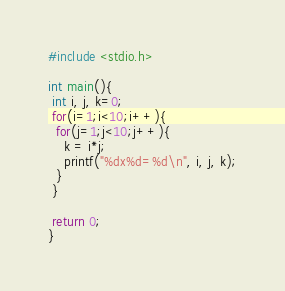Convert code to text. <code><loc_0><loc_0><loc_500><loc_500><_C_>#include <stdio.h>

int main(){
 int i, j, k=0;
 for(i=1;i<10;i++){
  for(j=1;j<10;j++){
    k = i*j;
    printf("%dx%d=%d\n", i, j, k);
  }
 }

 return 0;
}</code> 